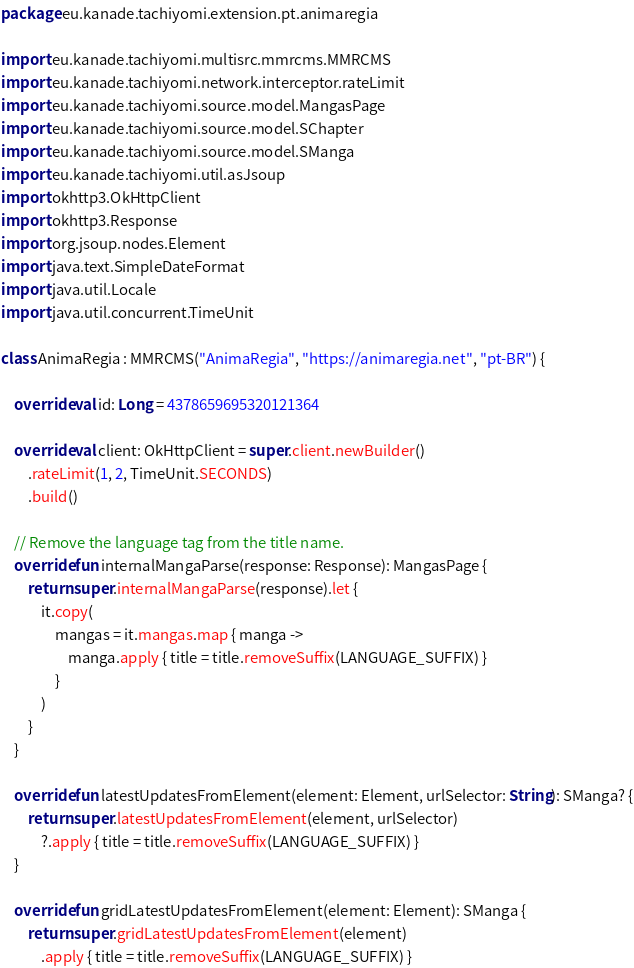Convert code to text. <code><loc_0><loc_0><loc_500><loc_500><_Kotlin_>package eu.kanade.tachiyomi.extension.pt.animaregia

import eu.kanade.tachiyomi.multisrc.mmrcms.MMRCMS
import eu.kanade.tachiyomi.network.interceptor.rateLimit
import eu.kanade.tachiyomi.source.model.MangasPage
import eu.kanade.tachiyomi.source.model.SChapter
import eu.kanade.tachiyomi.source.model.SManga
import eu.kanade.tachiyomi.util.asJsoup
import okhttp3.OkHttpClient
import okhttp3.Response
import org.jsoup.nodes.Element
import java.text.SimpleDateFormat
import java.util.Locale
import java.util.concurrent.TimeUnit

class AnimaRegia : MMRCMS("AnimaRegia", "https://animaregia.net", "pt-BR") {

    override val id: Long = 4378659695320121364

    override val client: OkHttpClient = super.client.newBuilder()
        .rateLimit(1, 2, TimeUnit.SECONDS)
        .build()

    // Remove the language tag from the title name.
    override fun internalMangaParse(response: Response): MangasPage {
        return super.internalMangaParse(response).let {
            it.copy(
                mangas = it.mangas.map { manga ->
                    manga.apply { title = title.removeSuffix(LANGUAGE_SUFFIX) }
                }
            )
        }
    }

    override fun latestUpdatesFromElement(element: Element, urlSelector: String): SManga? {
        return super.latestUpdatesFromElement(element, urlSelector)
            ?.apply { title = title.removeSuffix(LANGUAGE_SUFFIX) }
    }

    override fun gridLatestUpdatesFromElement(element: Element): SManga {
        return super.gridLatestUpdatesFromElement(element)
            .apply { title = title.removeSuffix(LANGUAGE_SUFFIX) }</code> 